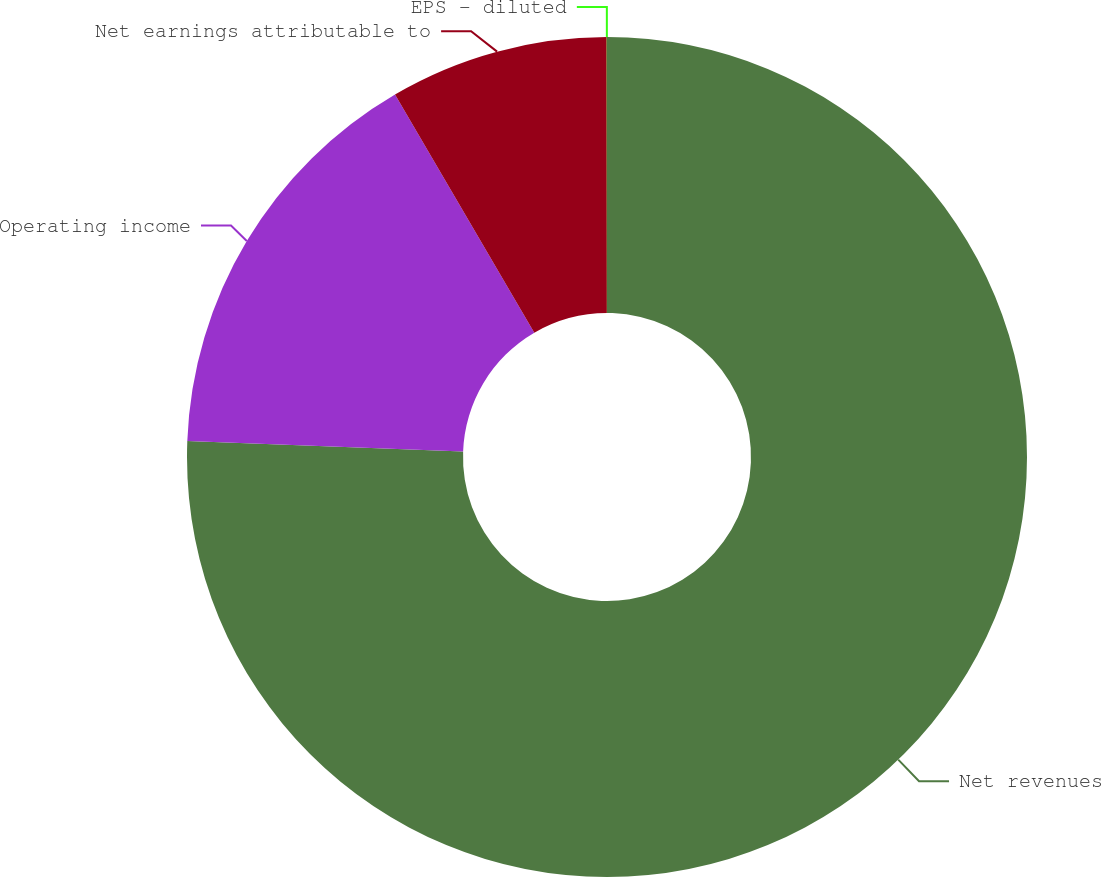<chart> <loc_0><loc_0><loc_500><loc_500><pie_chart><fcel>Net revenues<fcel>Operating income<fcel>Net earnings attributable to<fcel>EPS - diluted<nl><fcel>75.61%<fcel>15.97%<fcel>8.41%<fcel>0.01%<nl></chart> 